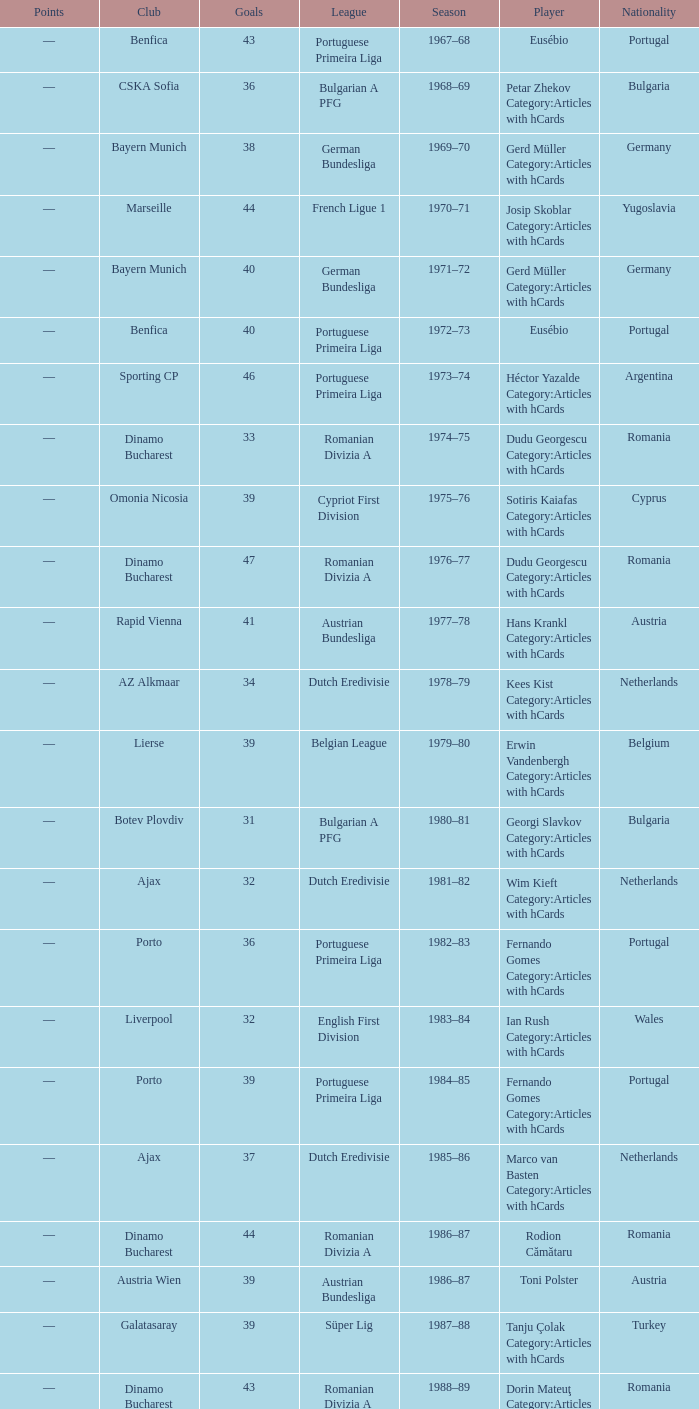Which league's nationality was Italy when there were 62 points? Italian Serie A. 